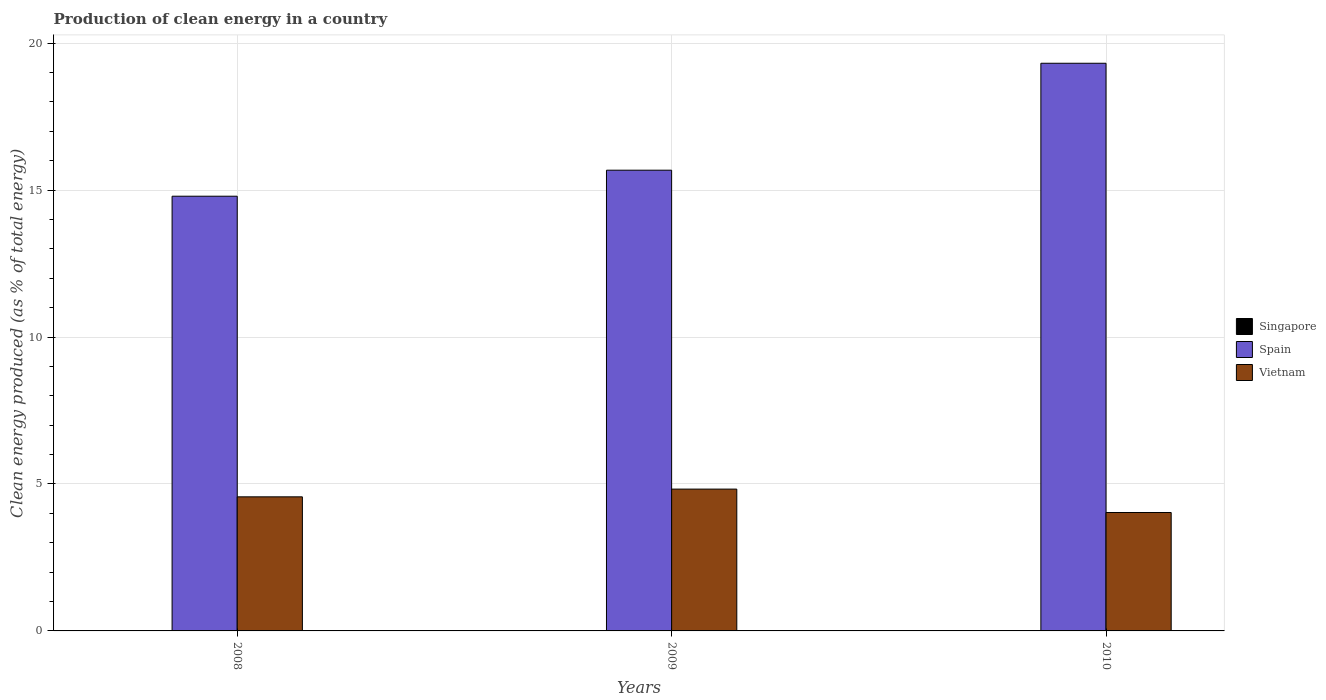Are the number of bars per tick equal to the number of legend labels?
Your answer should be very brief. Yes. How many bars are there on the 2nd tick from the left?
Offer a terse response. 3. What is the label of the 1st group of bars from the left?
Your response must be concise. 2008. In how many cases, is the number of bars for a given year not equal to the number of legend labels?
Offer a terse response. 0. What is the percentage of clean energy produced in Singapore in 2009?
Ensure brevity in your answer.  0. Across all years, what is the maximum percentage of clean energy produced in Spain?
Make the answer very short. 19.32. Across all years, what is the minimum percentage of clean energy produced in Spain?
Keep it short and to the point. 14.79. In which year was the percentage of clean energy produced in Singapore minimum?
Your response must be concise. 2008. What is the total percentage of clean energy produced in Spain in the graph?
Keep it short and to the point. 49.78. What is the difference between the percentage of clean energy produced in Singapore in 2008 and that in 2010?
Offer a very short reply. -0. What is the difference between the percentage of clean energy produced in Vietnam in 2010 and the percentage of clean energy produced in Singapore in 2009?
Give a very brief answer. 4.03. What is the average percentage of clean energy produced in Singapore per year?
Your answer should be very brief. 0. In the year 2010, what is the difference between the percentage of clean energy produced in Vietnam and percentage of clean energy produced in Spain?
Provide a short and direct response. -15.29. What is the ratio of the percentage of clean energy produced in Vietnam in 2008 to that in 2010?
Offer a terse response. 1.13. What is the difference between the highest and the second highest percentage of clean energy produced in Vietnam?
Provide a short and direct response. 0.26. What is the difference between the highest and the lowest percentage of clean energy produced in Singapore?
Make the answer very short. 0. What does the 3rd bar from the left in 2008 represents?
Give a very brief answer. Vietnam. What does the 1st bar from the right in 2010 represents?
Provide a short and direct response. Vietnam. How many bars are there?
Keep it short and to the point. 9. How are the legend labels stacked?
Your answer should be very brief. Vertical. What is the title of the graph?
Keep it short and to the point. Production of clean energy in a country. What is the label or title of the X-axis?
Your answer should be compact. Years. What is the label or title of the Y-axis?
Give a very brief answer. Clean energy produced (as % of total energy). What is the Clean energy produced (as % of total energy) in Singapore in 2008?
Provide a short and direct response. 0. What is the Clean energy produced (as % of total energy) in Spain in 2008?
Provide a succinct answer. 14.79. What is the Clean energy produced (as % of total energy) in Vietnam in 2008?
Provide a succinct answer. 4.56. What is the Clean energy produced (as % of total energy) of Singapore in 2009?
Your answer should be compact. 0. What is the Clean energy produced (as % of total energy) of Spain in 2009?
Offer a terse response. 15.68. What is the Clean energy produced (as % of total energy) of Vietnam in 2009?
Make the answer very short. 4.83. What is the Clean energy produced (as % of total energy) of Singapore in 2010?
Your answer should be very brief. 0. What is the Clean energy produced (as % of total energy) in Spain in 2010?
Make the answer very short. 19.32. What is the Clean energy produced (as % of total energy) of Vietnam in 2010?
Offer a terse response. 4.03. Across all years, what is the maximum Clean energy produced (as % of total energy) in Singapore?
Provide a short and direct response. 0. Across all years, what is the maximum Clean energy produced (as % of total energy) in Spain?
Give a very brief answer. 19.32. Across all years, what is the maximum Clean energy produced (as % of total energy) in Vietnam?
Keep it short and to the point. 4.83. Across all years, what is the minimum Clean energy produced (as % of total energy) of Singapore?
Ensure brevity in your answer.  0. Across all years, what is the minimum Clean energy produced (as % of total energy) of Spain?
Provide a short and direct response. 14.79. Across all years, what is the minimum Clean energy produced (as % of total energy) in Vietnam?
Give a very brief answer. 4.03. What is the total Clean energy produced (as % of total energy) of Singapore in the graph?
Your answer should be very brief. 0. What is the total Clean energy produced (as % of total energy) in Spain in the graph?
Make the answer very short. 49.78. What is the total Clean energy produced (as % of total energy) of Vietnam in the graph?
Ensure brevity in your answer.  13.42. What is the difference between the Clean energy produced (as % of total energy) in Singapore in 2008 and that in 2009?
Make the answer very short. -0. What is the difference between the Clean energy produced (as % of total energy) of Spain in 2008 and that in 2009?
Make the answer very short. -0.89. What is the difference between the Clean energy produced (as % of total energy) in Vietnam in 2008 and that in 2009?
Keep it short and to the point. -0.26. What is the difference between the Clean energy produced (as % of total energy) of Singapore in 2008 and that in 2010?
Provide a short and direct response. -0. What is the difference between the Clean energy produced (as % of total energy) of Spain in 2008 and that in 2010?
Your response must be concise. -4.52. What is the difference between the Clean energy produced (as % of total energy) in Vietnam in 2008 and that in 2010?
Keep it short and to the point. 0.53. What is the difference between the Clean energy produced (as % of total energy) in Singapore in 2009 and that in 2010?
Your answer should be very brief. -0. What is the difference between the Clean energy produced (as % of total energy) in Spain in 2009 and that in 2010?
Make the answer very short. -3.64. What is the difference between the Clean energy produced (as % of total energy) of Vietnam in 2009 and that in 2010?
Your response must be concise. 0.8. What is the difference between the Clean energy produced (as % of total energy) of Singapore in 2008 and the Clean energy produced (as % of total energy) of Spain in 2009?
Give a very brief answer. -15.68. What is the difference between the Clean energy produced (as % of total energy) of Singapore in 2008 and the Clean energy produced (as % of total energy) of Vietnam in 2009?
Ensure brevity in your answer.  -4.83. What is the difference between the Clean energy produced (as % of total energy) of Spain in 2008 and the Clean energy produced (as % of total energy) of Vietnam in 2009?
Make the answer very short. 9.97. What is the difference between the Clean energy produced (as % of total energy) in Singapore in 2008 and the Clean energy produced (as % of total energy) in Spain in 2010?
Offer a very short reply. -19.32. What is the difference between the Clean energy produced (as % of total energy) in Singapore in 2008 and the Clean energy produced (as % of total energy) in Vietnam in 2010?
Provide a succinct answer. -4.03. What is the difference between the Clean energy produced (as % of total energy) of Spain in 2008 and the Clean energy produced (as % of total energy) of Vietnam in 2010?
Make the answer very short. 10.76. What is the difference between the Clean energy produced (as % of total energy) of Singapore in 2009 and the Clean energy produced (as % of total energy) of Spain in 2010?
Ensure brevity in your answer.  -19.31. What is the difference between the Clean energy produced (as % of total energy) in Singapore in 2009 and the Clean energy produced (as % of total energy) in Vietnam in 2010?
Offer a very short reply. -4.03. What is the difference between the Clean energy produced (as % of total energy) in Spain in 2009 and the Clean energy produced (as % of total energy) in Vietnam in 2010?
Ensure brevity in your answer.  11.65. What is the average Clean energy produced (as % of total energy) of Singapore per year?
Your answer should be compact. 0. What is the average Clean energy produced (as % of total energy) of Spain per year?
Ensure brevity in your answer.  16.59. What is the average Clean energy produced (as % of total energy) in Vietnam per year?
Ensure brevity in your answer.  4.47. In the year 2008, what is the difference between the Clean energy produced (as % of total energy) of Singapore and Clean energy produced (as % of total energy) of Spain?
Provide a short and direct response. -14.79. In the year 2008, what is the difference between the Clean energy produced (as % of total energy) in Singapore and Clean energy produced (as % of total energy) in Vietnam?
Ensure brevity in your answer.  -4.56. In the year 2008, what is the difference between the Clean energy produced (as % of total energy) in Spain and Clean energy produced (as % of total energy) in Vietnam?
Your response must be concise. 10.23. In the year 2009, what is the difference between the Clean energy produced (as % of total energy) in Singapore and Clean energy produced (as % of total energy) in Spain?
Provide a succinct answer. -15.68. In the year 2009, what is the difference between the Clean energy produced (as % of total energy) in Singapore and Clean energy produced (as % of total energy) in Vietnam?
Your response must be concise. -4.82. In the year 2009, what is the difference between the Clean energy produced (as % of total energy) in Spain and Clean energy produced (as % of total energy) in Vietnam?
Give a very brief answer. 10.85. In the year 2010, what is the difference between the Clean energy produced (as % of total energy) in Singapore and Clean energy produced (as % of total energy) in Spain?
Your answer should be very brief. -19.31. In the year 2010, what is the difference between the Clean energy produced (as % of total energy) in Singapore and Clean energy produced (as % of total energy) in Vietnam?
Give a very brief answer. -4.03. In the year 2010, what is the difference between the Clean energy produced (as % of total energy) in Spain and Clean energy produced (as % of total energy) in Vietnam?
Your response must be concise. 15.29. What is the ratio of the Clean energy produced (as % of total energy) of Singapore in 2008 to that in 2009?
Your answer should be compact. 0.28. What is the ratio of the Clean energy produced (as % of total energy) in Spain in 2008 to that in 2009?
Offer a terse response. 0.94. What is the ratio of the Clean energy produced (as % of total energy) of Vietnam in 2008 to that in 2009?
Your answer should be compact. 0.95. What is the ratio of the Clean energy produced (as % of total energy) in Singapore in 2008 to that in 2010?
Your response must be concise. 0.21. What is the ratio of the Clean energy produced (as % of total energy) of Spain in 2008 to that in 2010?
Offer a very short reply. 0.77. What is the ratio of the Clean energy produced (as % of total energy) of Vietnam in 2008 to that in 2010?
Your response must be concise. 1.13. What is the ratio of the Clean energy produced (as % of total energy) in Singapore in 2009 to that in 2010?
Give a very brief answer. 0.75. What is the ratio of the Clean energy produced (as % of total energy) of Spain in 2009 to that in 2010?
Offer a very short reply. 0.81. What is the ratio of the Clean energy produced (as % of total energy) in Vietnam in 2009 to that in 2010?
Ensure brevity in your answer.  1.2. What is the difference between the highest and the second highest Clean energy produced (as % of total energy) in Singapore?
Offer a very short reply. 0. What is the difference between the highest and the second highest Clean energy produced (as % of total energy) in Spain?
Keep it short and to the point. 3.64. What is the difference between the highest and the second highest Clean energy produced (as % of total energy) of Vietnam?
Your response must be concise. 0.26. What is the difference between the highest and the lowest Clean energy produced (as % of total energy) of Singapore?
Provide a short and direct response. 0. What is the difference between the highest and the lowest Clean energy produced (as % of total energy) of Spain?
Ensure brevity in your answer.  4.52. What is the difference between the highest and the lowest Clean energy produced (as % of total energy) in Vietnam?
Your answer should be very brief. 0.8. 